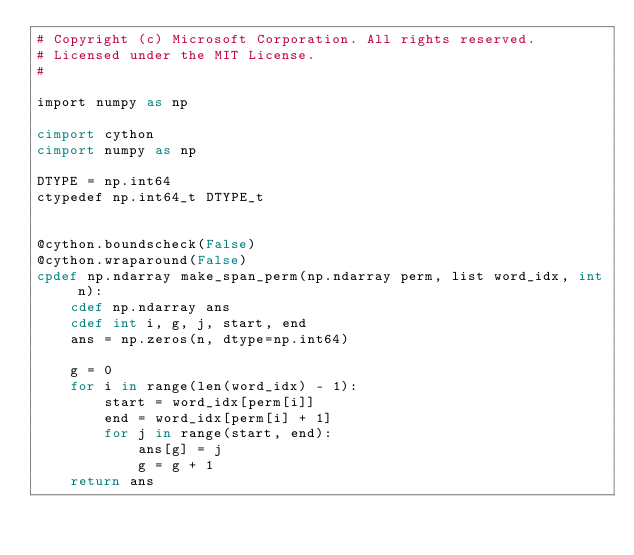<code> <loc_0><loc_0><loc_500><loc_500><_Cython_># Copyright (c) Microsoft Corporation. All rights reserved.
# Licensed under the MIT License.
#

import numpy as np

cimport cython
cimport numpy as np

DTYPE = np.int64
ctypedef np.int64_t DTYPE_t


@cython.boundscheck(False)
@cython.wraparound(False)
cpdef np.ndarray make_span_perm(np.ndarray perm, list word_idx, int n):
    cdef np.ndarray ans
    cdef int i, g, j, start, end
    ans = np.zeros(n, dtype=np.int64)

    g = 0
    for i in range(len(word_idx) - 1):
        start = word_idx[perm[i]]
        end = word_idx[perm[i] + 1]
        for j in range(start, end):
            ans[g] = j
            g = g + 1
    return ans
</code> 